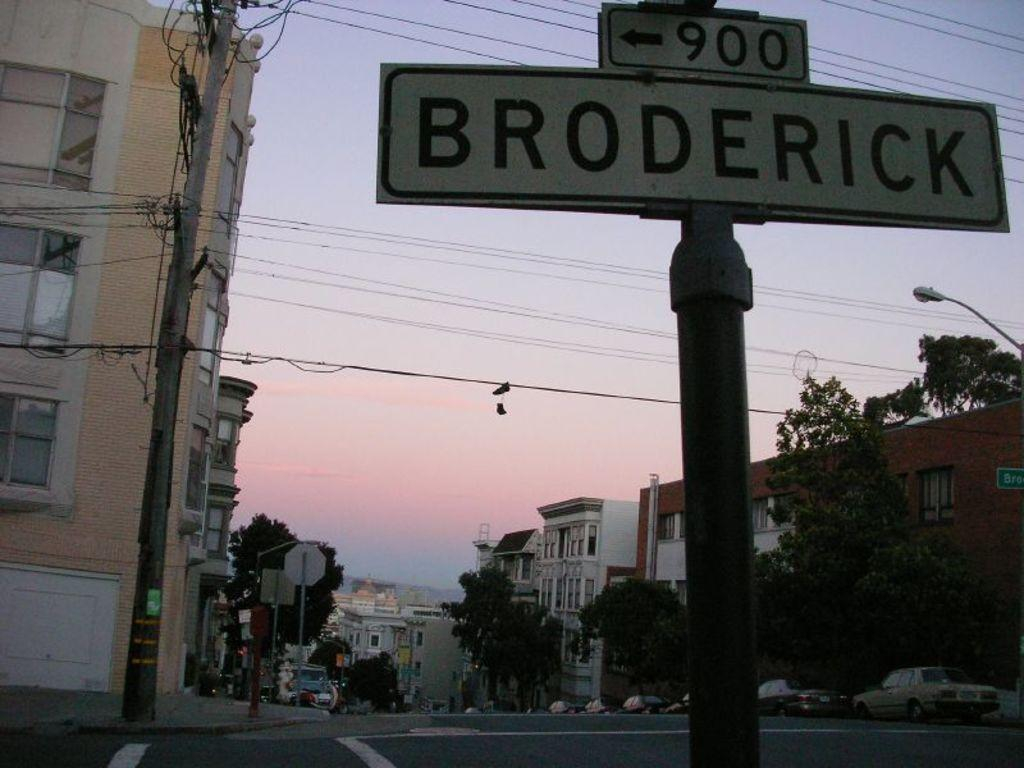What is located on the right side of the image? There is a sign pole on the right side of the image. What can be seen in the background of the image? There are buildings, trees, and vehicles in the background of the image. How many buildings are visible in the background? There are at least two buildings visible in the background. What type of advertisement can be seen on the volleyball in the image? There is no volleyball present in the image, and therefore no advertisement can be seen on it. 